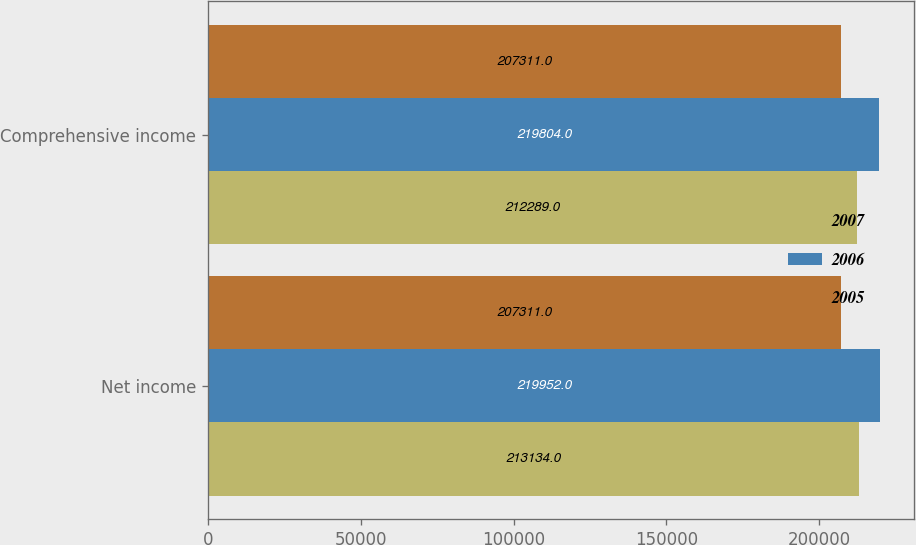Convert chart to OTSL. <chart><loc_0><loc_0><loc_500><loc_500><stacked_bar_chart><ecel><fcel>Net income<fcel>Comprehensive income<nl><fcel>2007<fcel>213134<fcel>212289<nl><fcel>2006<fcel>219952<fcel>219804<nl><fcel>2005<fcel>207311<fcel>207311<nl></chart> 